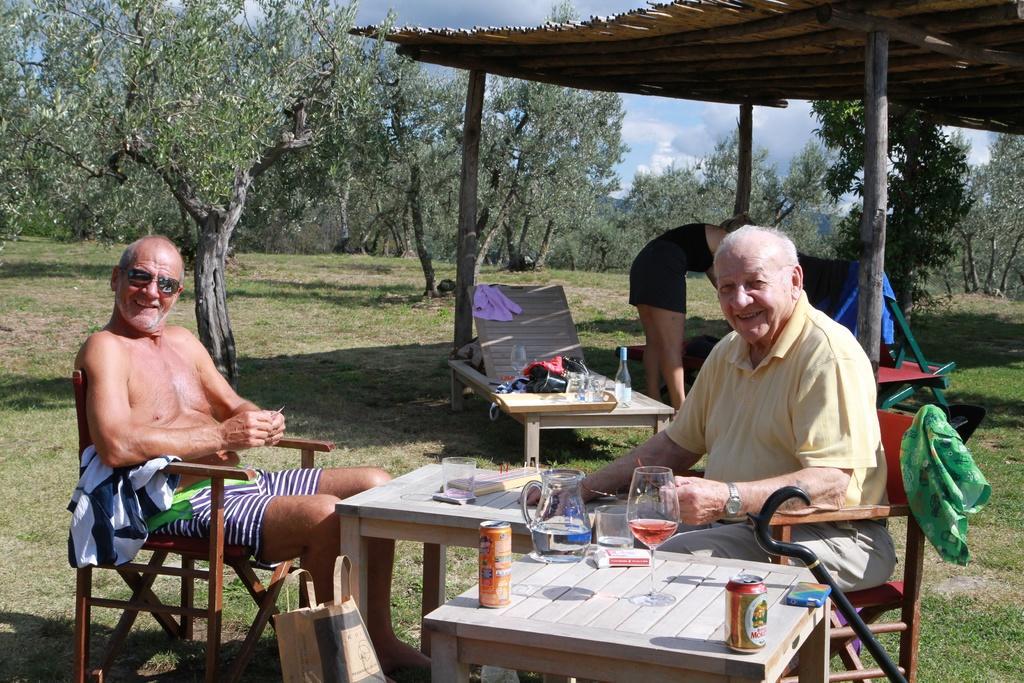Please provide a concise description of this image. In the picture there is a tree with lots of branches ,There is a grass some land over that and a man sitting on the chair, smiling. He wear a shades there is a table over here , glass and another man sitting on the chair he wearing a watch and he is also smiling. There is a tin over here. There is a bag here. And a woman is standing in the backside of them. There is a bottle in the bench. Sky is cloudy there are many clouds in the sky 